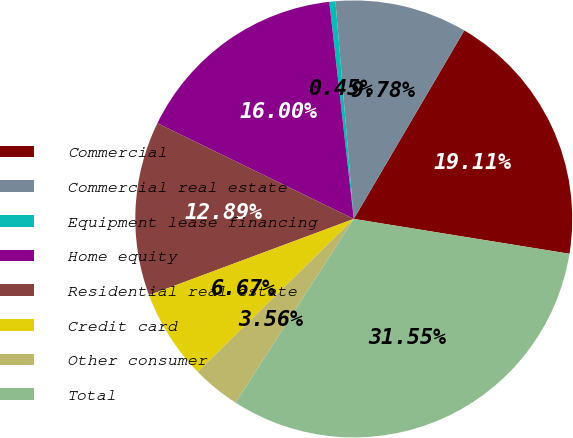<chart> <loc_0><loc_0><loc_500><loc_500><pie_chart><fcel>Commercial<fcel>Commercial real estate<fcel>Equipment lease financing<fcel>Home equity<fcel>Residential real estate<fcel>Credit card<fcel>Other consumer<fcel>Total<nl><fcel>19.11%<fcel>9.78%<fcel>0.45%<fcel>16.0%<fcel>12.89%<fcel>6.67%<fcel>3.56%<fcel>31.55%<nl></chart> 